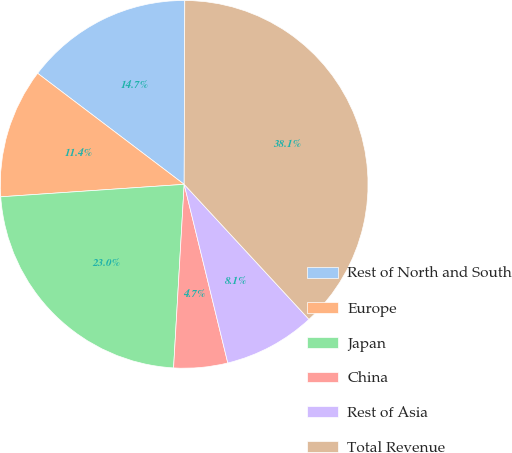<chart> <loc_0><loc_0><loc_500><loc_500><pie_chart><fcel>Rest of North and South<fcel>Europe<fcel>Japan<fcel>China<fcel>Rest of Asia<fcel>Total Revenue<nl><fcel>14.73%<fcel>11.4%<fcel>23.0%<fcel>4.73%<fcel>8.06%<fcel>38.07%<nl></chart> 